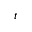<formula> <loc_0><loc_0><loc_500><loc_500>t</formula> 